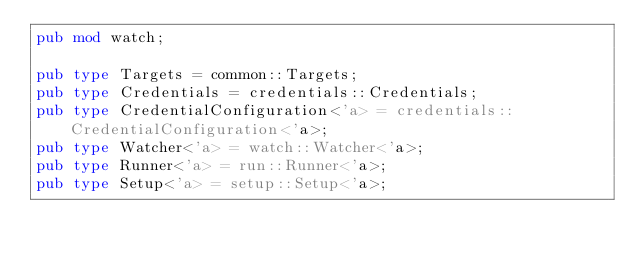<code> <loc_0><loc_0><loc_500><loc_500><_Rust_>pub mod watch;

pub type Targets = common::Targets;
pub type Credentials = credentials::Credentials;
pub type CredentialConfiguration<'a> = credentials::CredentialConfiguration<'a>;
pub type Watcher<'a> = watch::Watcher<'a>;
pub type Runner<'a> = run::Runner<'a>;
pub type Setup<'a> = setup::Setup<'a>;
</code> 